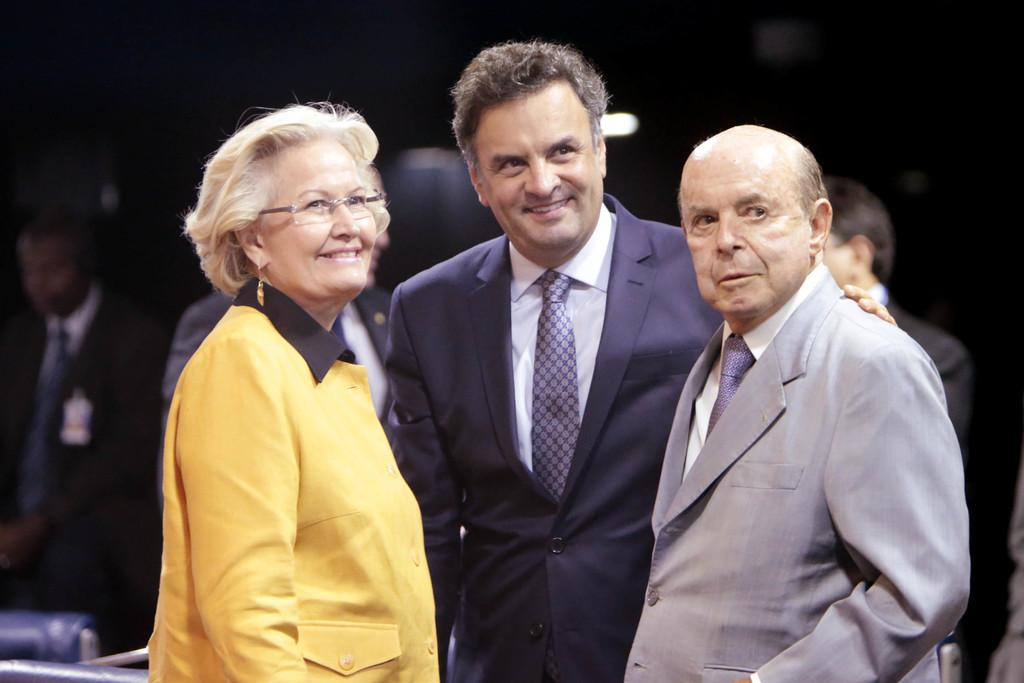How many people are in the main group in the image? There are three persons in the middle of the image. What can be seen on the left side of the image? There is a woman on the left side of the image. What accessory is the woman wearing? The woman is wearing spectacles. Can you describe the people in the background of the image? There are other people in the background of the image. What type of zinc is being used for tax purposes in the image? There is no mention of zinc or tax in the image; it features three persons and a woman on the left side. What selection process is being depicted in the image? There is no selection process depicted in the image; it simply shows a group of people and a woman wearing spectacles. 